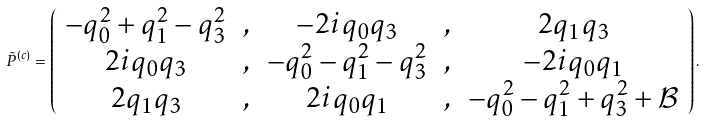Convert formula to latex. <formula><loc_0><loc_0><loc_500><loc_500>\tilde { P } ^ { ( c ) } = \left ( \begin{array} { c c c c c } - q _ { 0 } ^ { 2 } + q _ { 1 } ^ { 2 } - q _ { 3 } ^ { 2 } & , & - 2 i q _ { 0 } q _ { 3 } & , & 2 q _ { 1 } q _ { 3 } \\ 2 i q _ { 0 } q _ { 3 } & , & - q _ { 0 } ^ { 2 } - q _ { 1 } ^ { 2 } - q _ { 3 } ^ { 2 } & , & - 2 i q _ { 0 } q _ { 1 } \\ 2 q _ { 1 } q _ { 3 } & , & 2 i q _ { 0 } q _ { 1 } & , & - q _ { 0 } ^ { 2 } - q _ { 1 } ^ { 2 } + q _ { 3 } ^ { 2 } + \mathcal { B } \end{array} \right ) .</formula> 